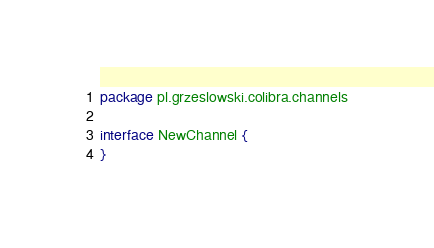Convert code to text. <code><loc_0><loc_0><loc_500><loc_500><_Kotlin_>package pl.grzeslowski.colibra.channels

interface NewChannel {
}</code> 